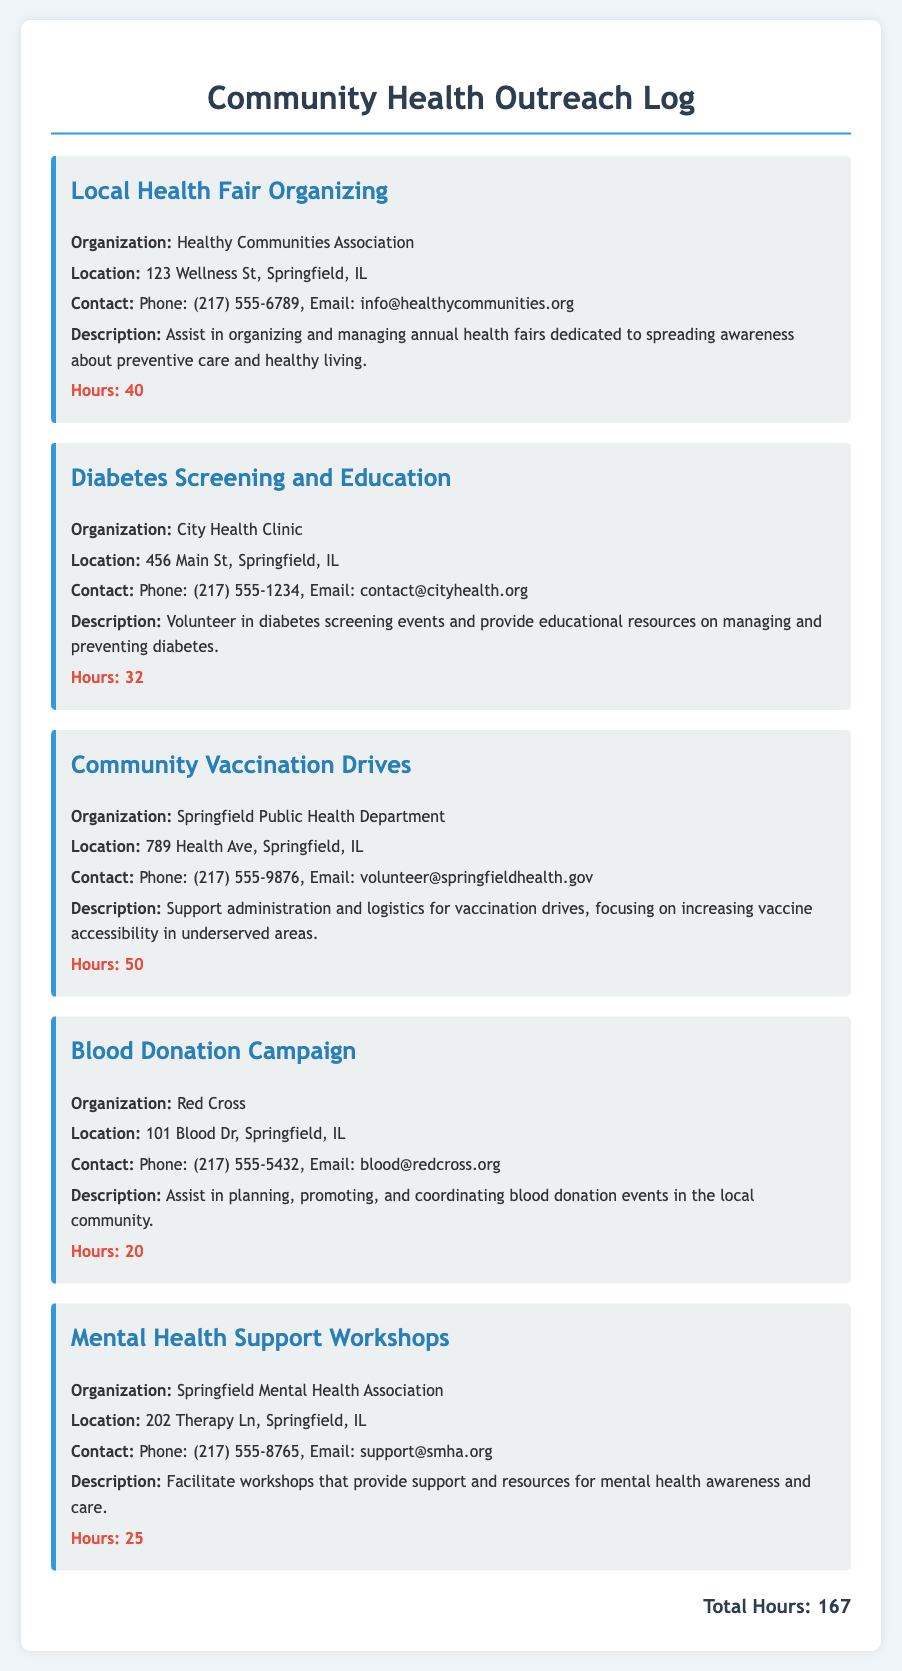What organization is responsible for the local health fair? The document states that the Healthy Communities Association is the organization responsible for organizing the local health fair.
Answer: Healthy Communities Association How many hours were dedicated to diabetes screening and education? The document specifies that a total of 32 hours were dedicated to diabetes screening and education activities.
Answer: 32 What is the contact email for the Springfield Public Health Department? The document provides the email address as volunteer@springfieldhealth.gov for contacting the Springfield Public Health Department.
Answer: volunteer@springfieldhealth.gov Which activity involves mental health support? According to the document, the activity that involves mental health support is titled "Mental Health Support Workshops."
Answer: Mental Health Support Workshops How many total hours were volunteered in community health activities? The total hours volunteered in all community health activities, as stated in the document, is 167 hours.
Answer: 167 Where is the Blood Donation Campaign located? The document indicates the Blood Donation Campaign is located at 101 Blood Dr, Springfield, IL.
Answer: 101 Blood Dr, Springfield, IL What is the purpose of the community vaccination drives? The document describes that the purpose of the community vaccination drives is to increase vaccine accessibility in underserved areas.
Answer: Increase vaccine accessibility in underserved areas Which organization is associated with blood donation events? The document names the Red Cross as the organization associated with planning and coordinating blood donation events.
Answer: Red Cross What is the phone number for the City Health Clinic? The document lists the phone number for the City Health Clinic as (217) 555-1234.
Answer: (217) 555-1234 